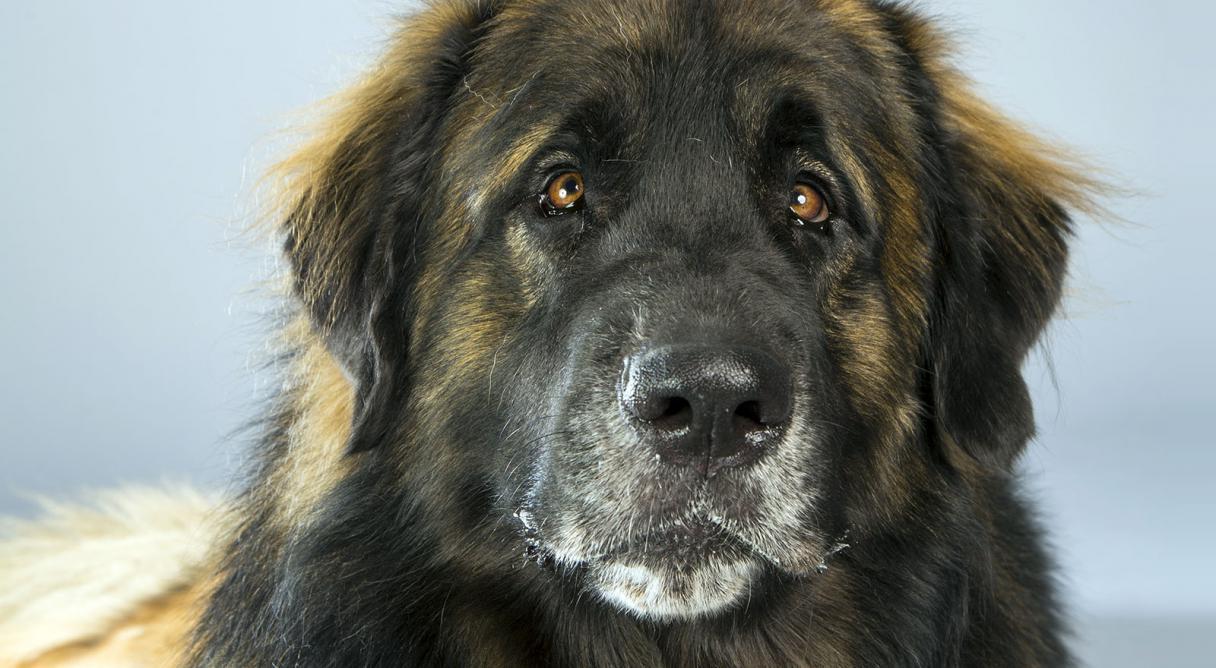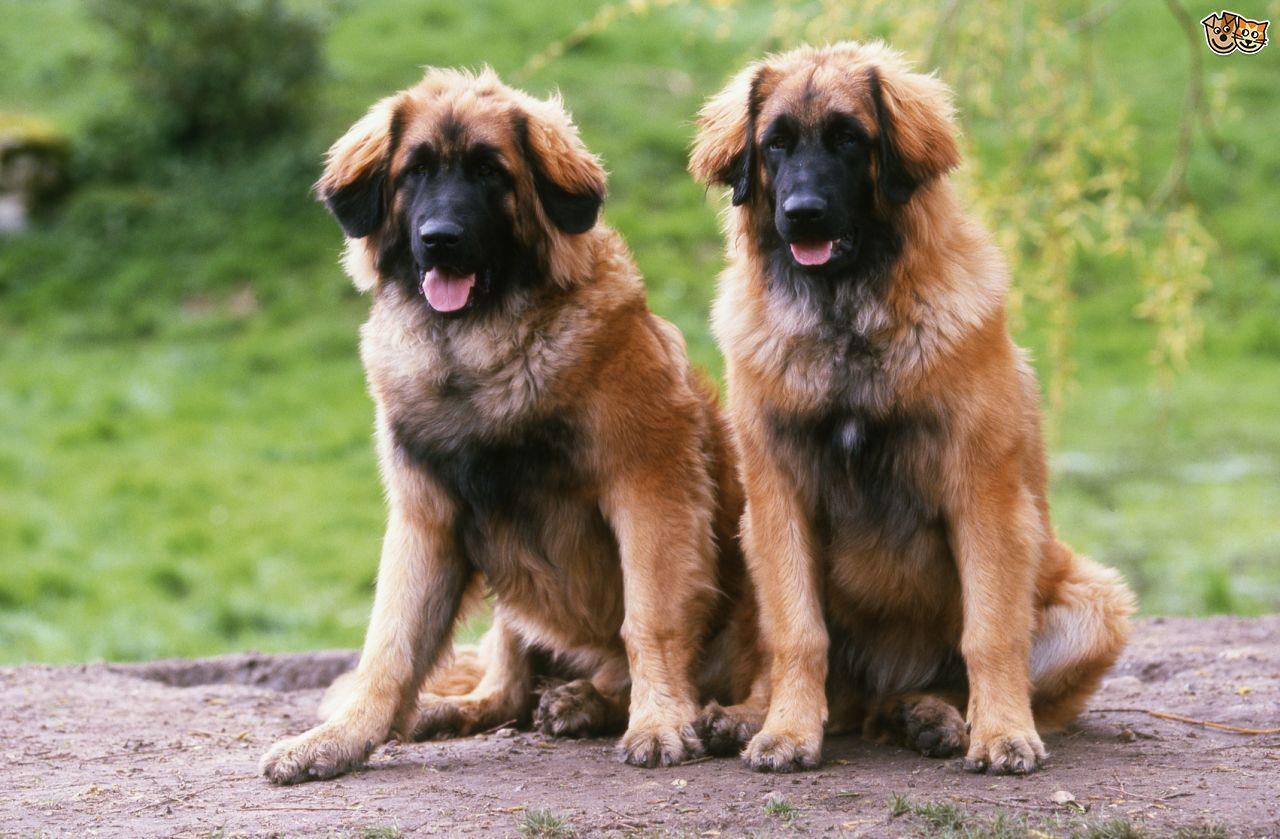The first image is the image on the left, the second image is the image on the right. Assess this claim about the two images: "Some dogs are sitting on the ground.". Correct or not? Answer yes or no. Yes. 